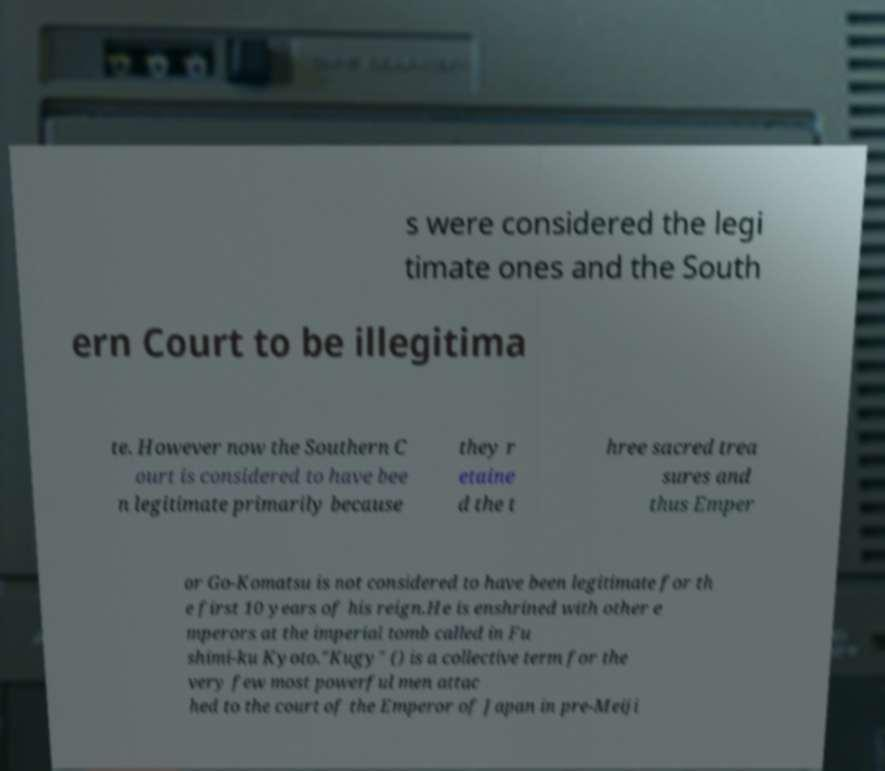Could you assist in decoding the text presented in this image and type it out clearly? s were considered the legi timate ones and the South ern Court to be illegitima te. However now the Southern C ourt is considered to have bee n legitimate primarily because they r etaine d the t hree sacred trea sures and thus Emper or Go-Komatsu is not considered to have been legitimate for th e first 10 years of his reign.He is enshrined with other e mperors at the imperial tomb called in Fu shimi-ku Kyoto."Kugy" () is a collective term for the very few most powerful men attac hed to the court of the Emperor of Japan in pre-Meiji 